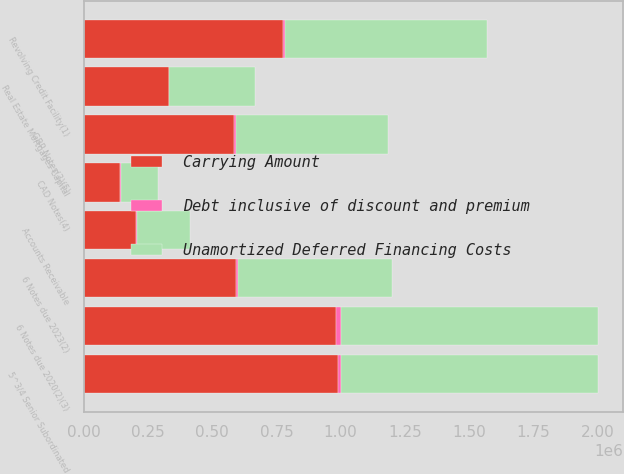Convert chart to OTSL. <chart><loc_0><loc_0><loc_500><loc_500><stacked_bar_chart><ecel><fcel>Revolving Credit Facility(1)<fcel>6 Notes due 2020(2)(3)<fcel>CAD Notes(4)<fcel>GBP Notes(3)(5)<fcel>6 Notes due 2023(2)<fcel>5^3/4 Senior Subordinated<fcel>Real Estate Mortgages Capital<fcel>Accounts Receivable<nl><fcel>Unamortized Deferred Financing Costs<fcel>784438<fcel>1e+06<fcel>144190<fcel>592140<fcel>600000<fcel>1e+06<fcel>333559<fcel>205900<nl><fcel>Debt inclusive of discount and premium<fcel>9410<fcel>16124<fcel>1924<fcel>8757<fcel>8420<fcel>11902<fcel>1070<fcel>692<nl><fcel>Carrying Amount<fcel>775028<fcel>983876<fcel>142266<fcel>583383<fcel>591580<fcel>988098<fcel>332489<fcel>205208<nl></chart> 